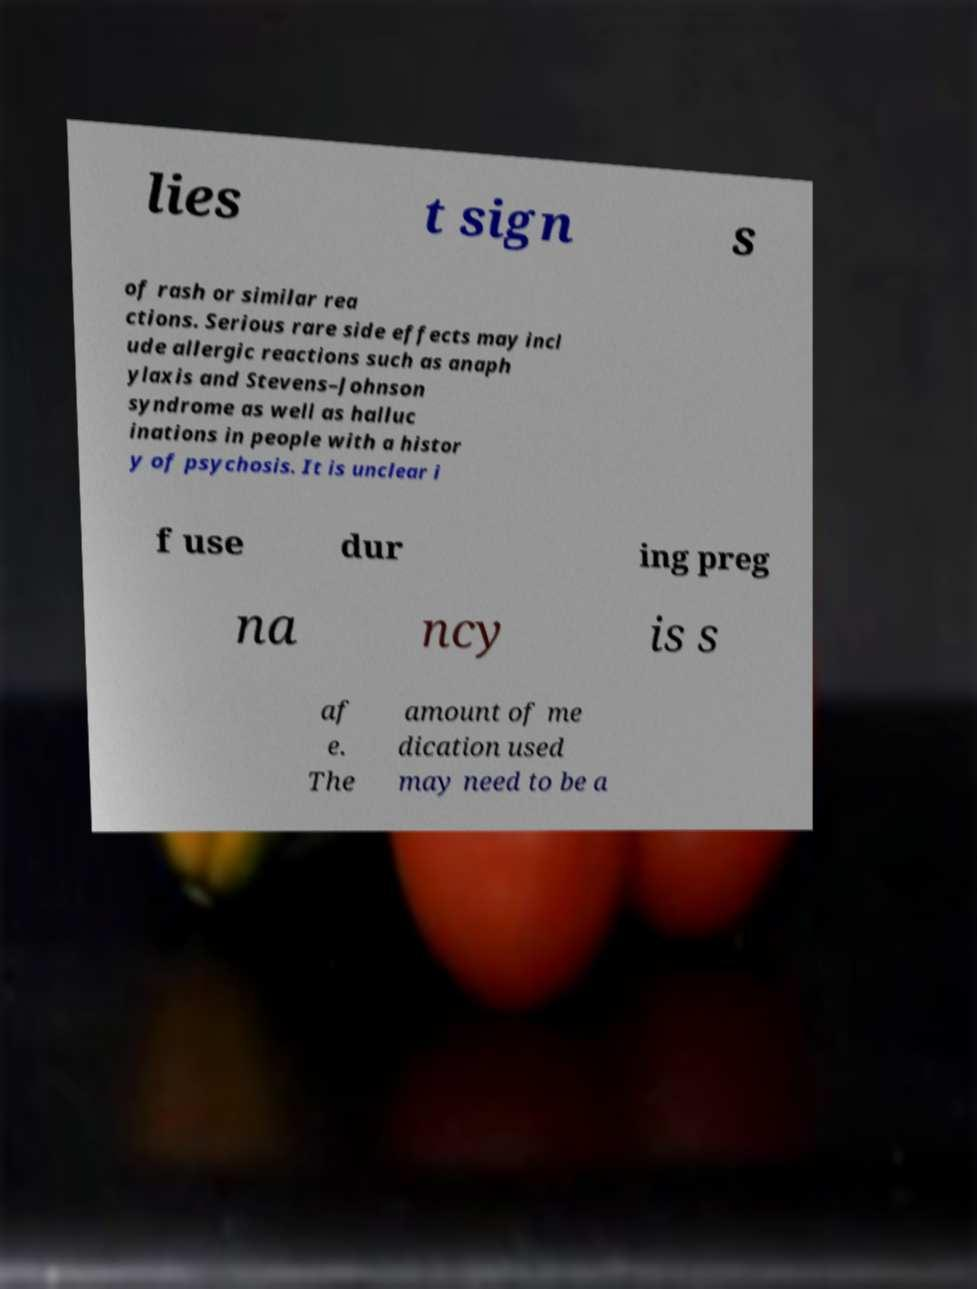Could you extract and type out the text from this image? lies t sign s of rash or similar rea ctions. Serious rare side effects may incl ude allergic reactions such as anaph ylaxis and Stevens–Johnson syndrome as well as halluc inations in people with a histor y of psychosis. It is unclear i f use dur ing preg na ncy is s af e. The amount of me dication used may need to be a 